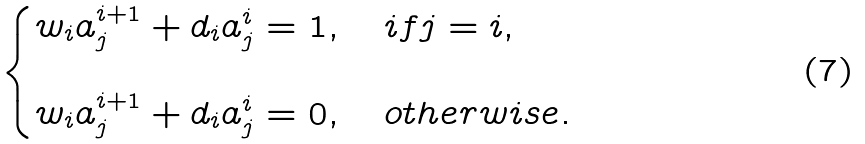<formula> <loc_0><loc_0><loc_500><loc_500>\begin{cases} w _ { i } a _ { j } ^ { i + 1 } + d _ { i } a _ { j } ^ { i } = 1 , & \, i f j = i , \\ \\ w _ { i } a _ { j } ^ { i + 1 } + d _ { i } a _ { j } ^ { i } = 0 , & \, o t h e r w i s e . \end{cases}</formula> 